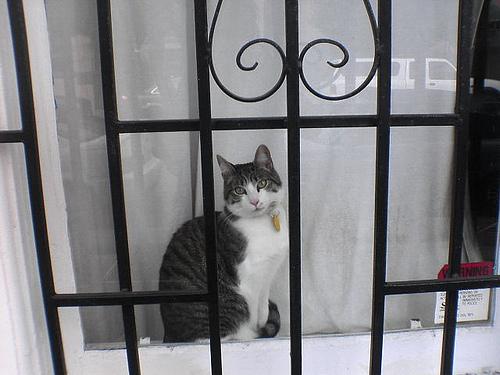What colors are on the cat?
Short answer required. Gray and white. What is looking at you?
Short answer required. Cat. What kind of sticker is on the window?
Quick response, please. Warning. Is the cat lonely?
Concise answer only. No. 